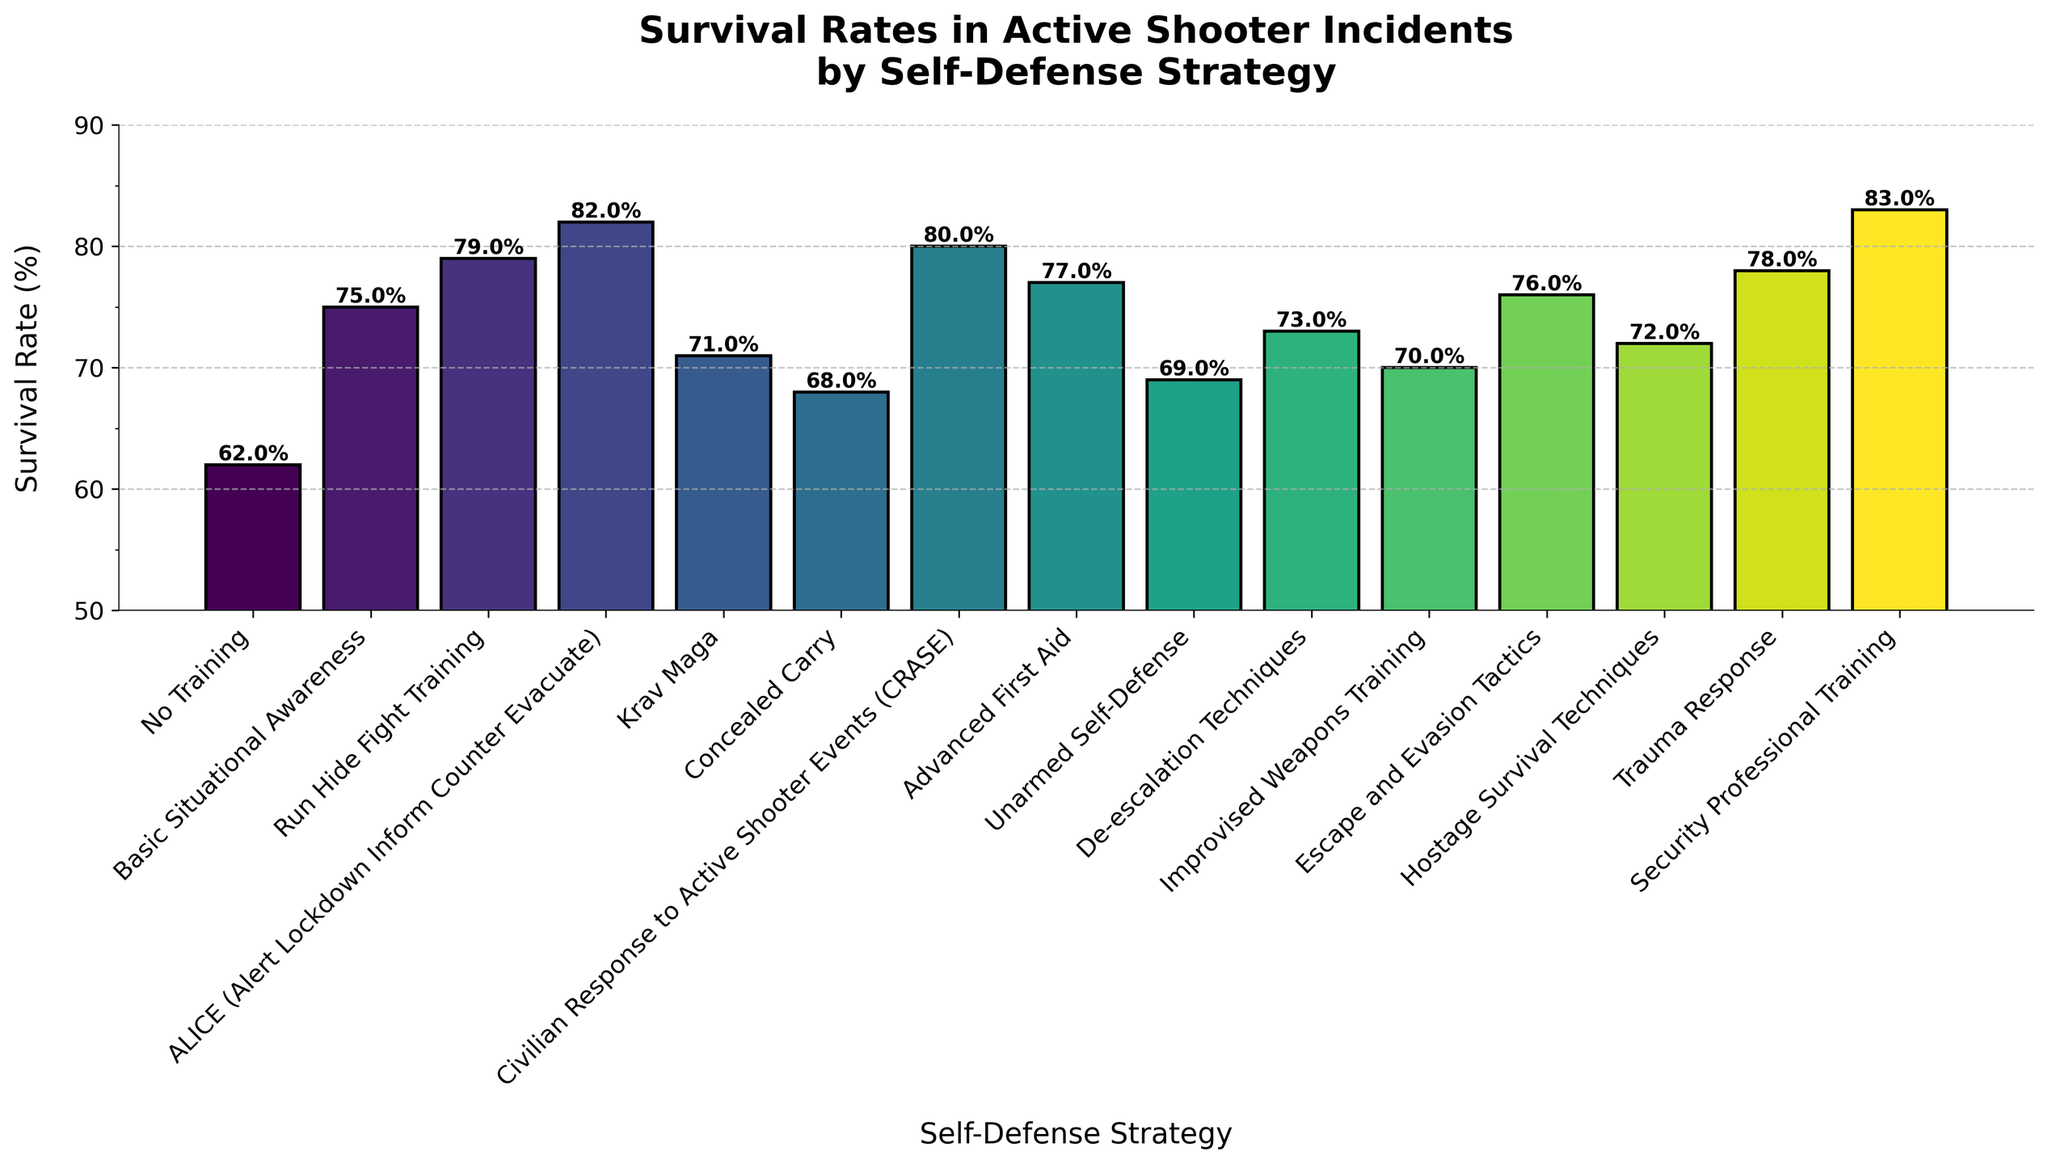What's the average survival rate of the strategies? Add all the survival rates and divide by the number of strategies: (62 + 75 + 79 + 82 + 71 + 68 + 80 + 77 + 69 + 73 + 70 + 76 + 72 + 78 + 83) / 15 = 1065 / 15
Answer: 71 Which strategy has the highest survival rate? Locate the bar with the maximum height. The tallest bar corresponds to the "Security Professional Training" strategy with a survival rate of 83%.
Answer: Security Professional Training Which strategy has the lowest survival rate? Locate the bar with the minimum height. The shortest bar corresponds to the "No Training" strategy with a survival rate of 62%.
Answer: No Training What is the difference in survival rate between "Run Hide Fight Training" and "Krav Maga"? Subtract the survival rate of "Krav Maga" (71%) from "Run Hide Fight Training" (79%): 79 - 71 = 8%
Answer: 8% Are there more strategies with survival rates above or below 75%? Count the number of strategies above 75% (79, 82, 80, 77, 76, 78, 83) = 7 and below 75% (62, 71, 68, 69, 73, 70, 72) = 7.
Answer: Equal How much higher is the survival rate for "De-escalation Techniques" compared to "Concealed Carry"? Subtract the survival rate of "Concealed Carry" (68%) from "De-escalation Techniques" (73%): 73 - 68 = 5%
Answer: 5% What's the median survival rate of the strategies? Arrange the survival rates in ascending order and find the middle value: 62, 68, 69, 70, 71, 72, 73, 75, 76, 77, 78, 79, 80, 82, 83. The middle value is 75%.
Answer: 75% Which has a higher survival rate: "ALICE" or "CRASE"? Compare the survival rates directly: ALICE (82%) and CRASE (80%). ALICE has a higher survival rate.
Answer: ALICE What is the combined survival rate of the top three strategies? Add the survival rates of the top three strategies: Security Professional Training (83%), ALICE (82%), and CRASE (80%): 83 + 82 + 80 = 245%
Answer: 245% How does the survival rate of "Advanced First Aid" compare to the average survival rate? The average survival rate is 71%. "Advanced First Aid" has a survival rate of 77%, which is higher than the average: 77% > 71%.
Answer: Higher 